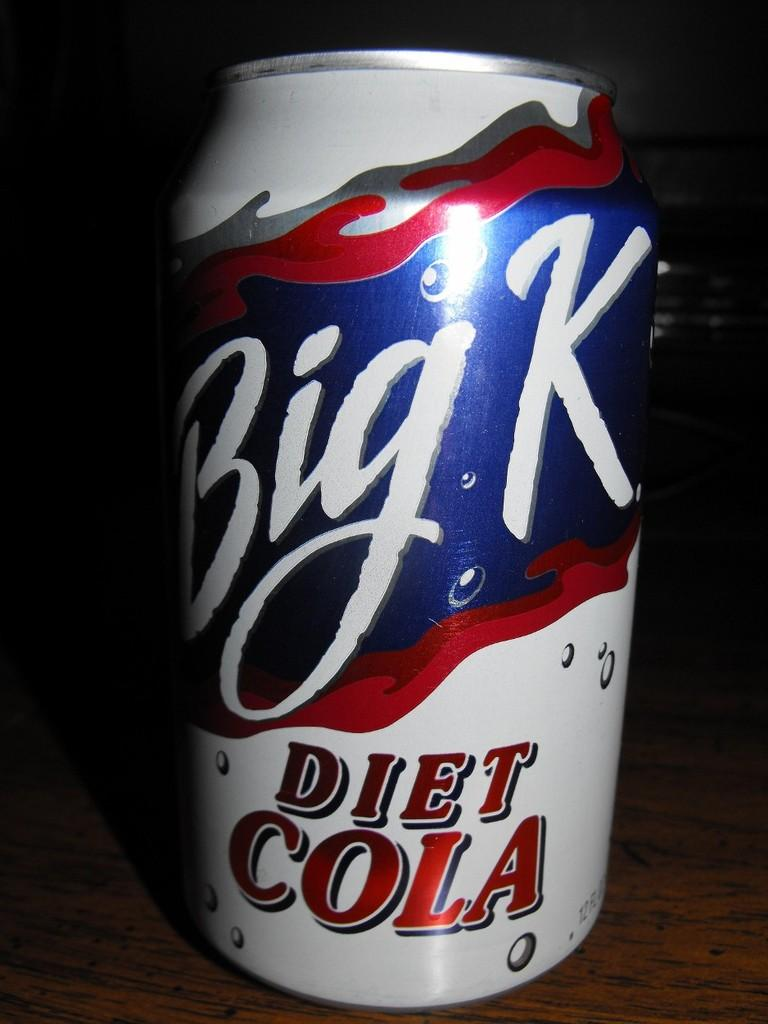Provide a one-sentence caption for the provided image. a Bik K soda that is on the ground. 